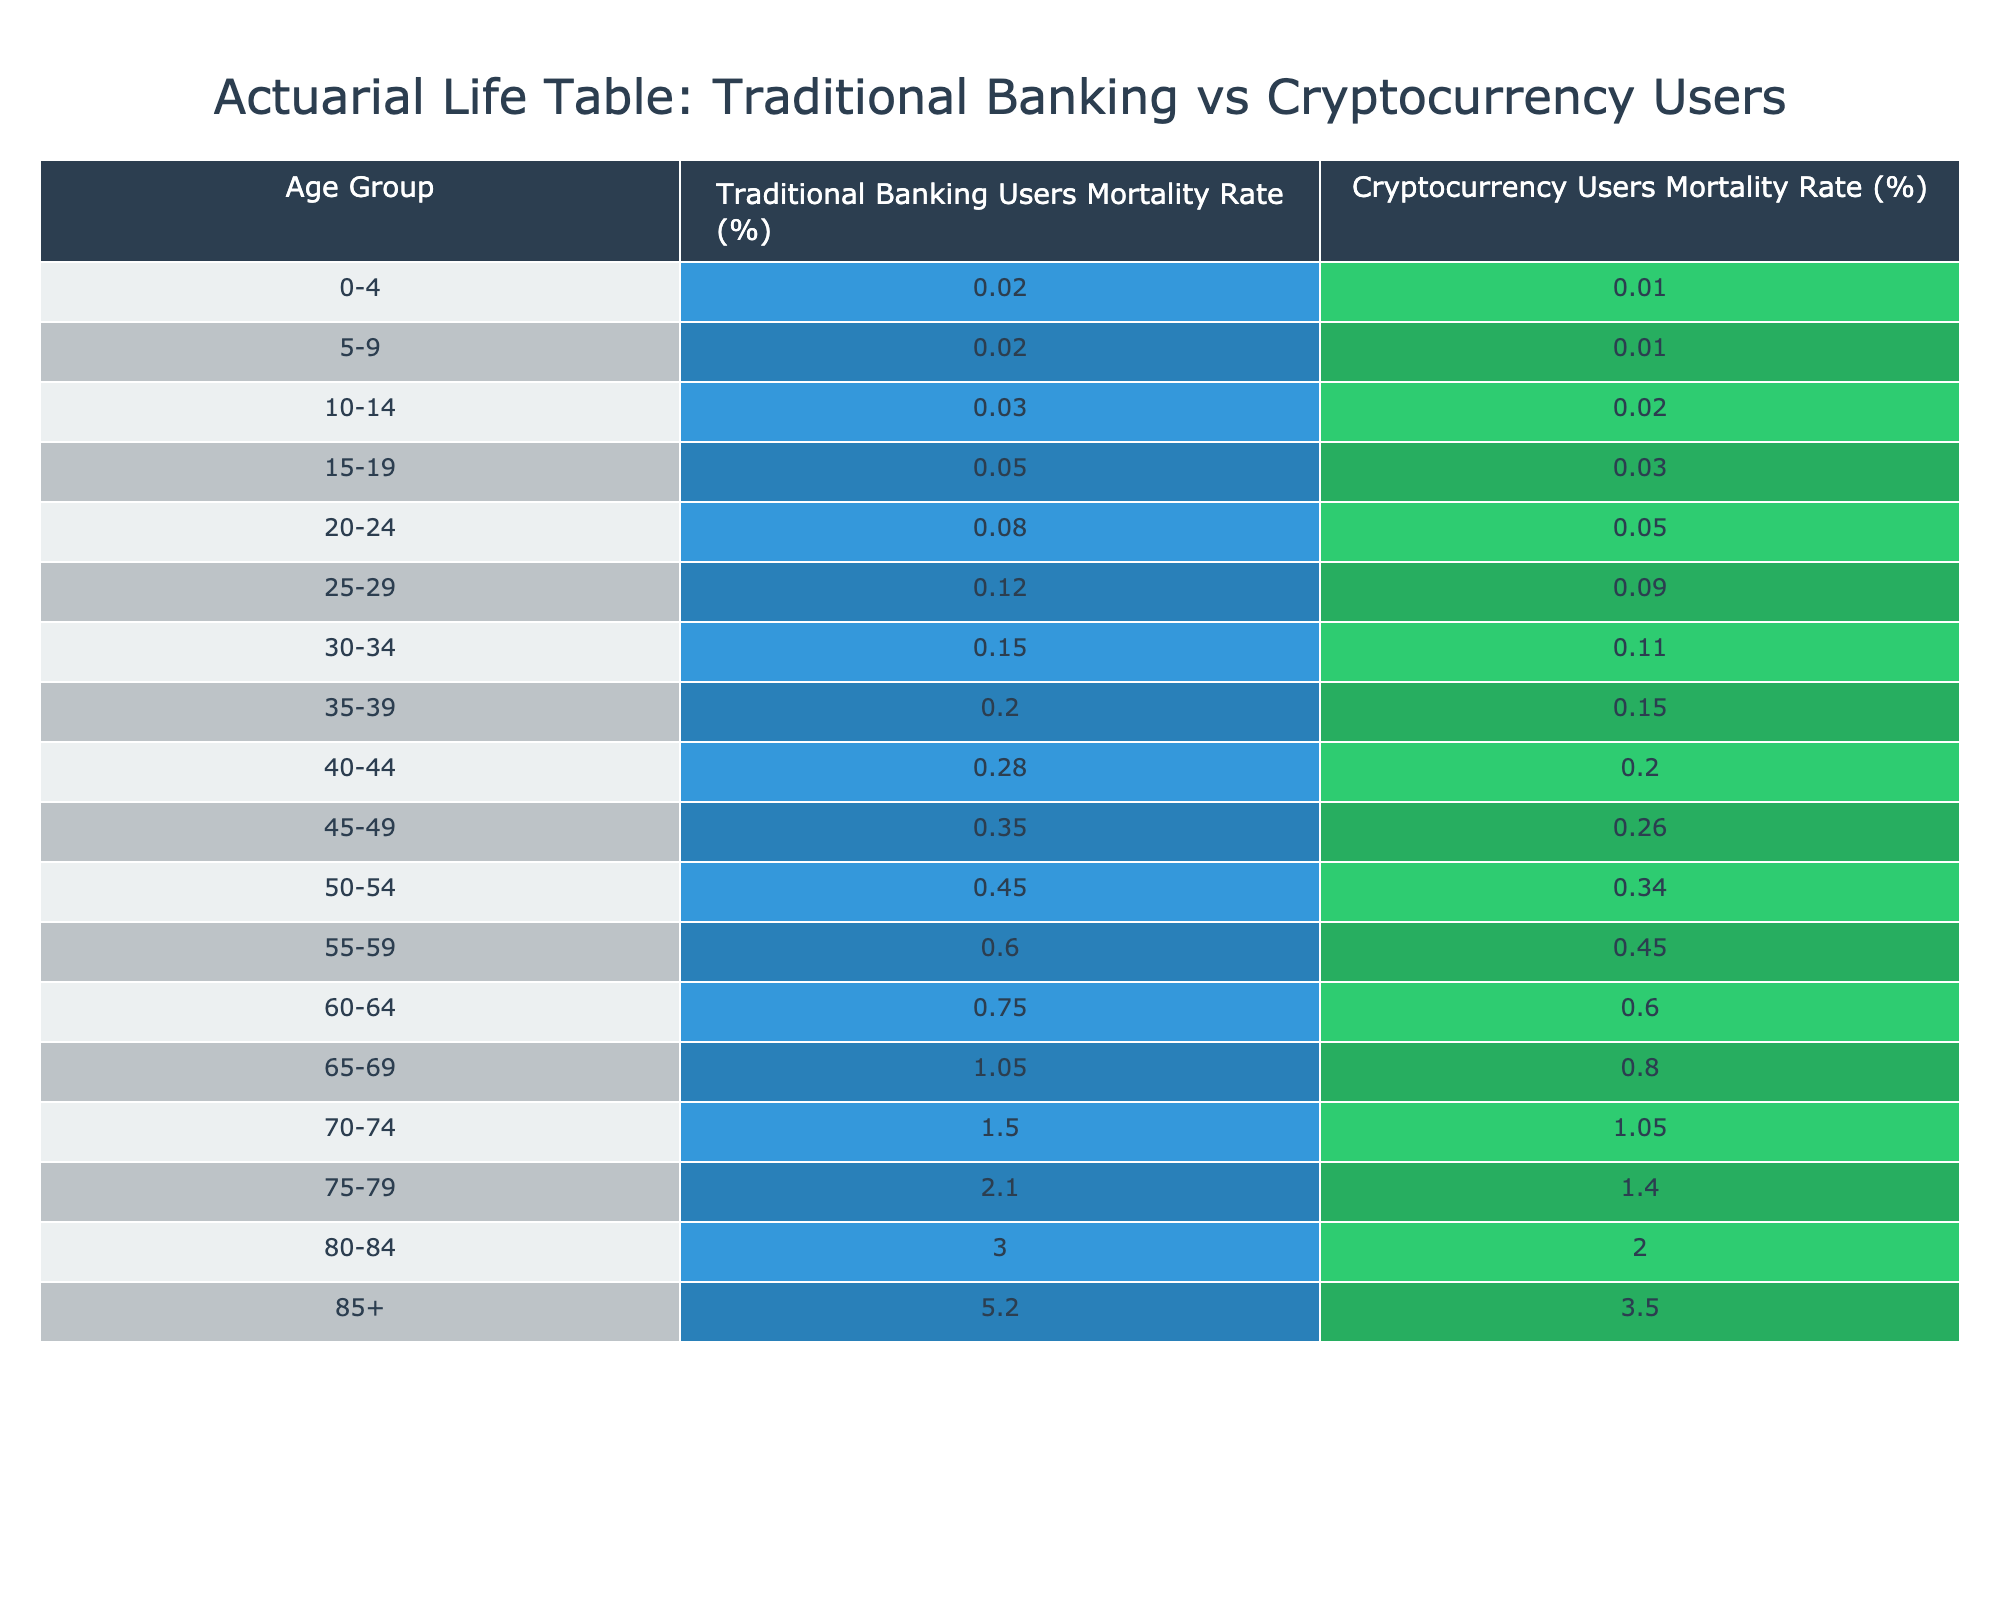What is the mortality rate for cryptocurrency users aged 60-64? The table shows the mortality rate for the age group 60-64 in the column for cryptocurrency users. The rate provided is 0.60%.
Answer: 0.60% Which age group has the highest mortality rate among traditional banking users? By examining the table, the highest mortality rate in the traditional banking users is found in the age group 85+, which is 5.20%.
Answer: 5.20% What is the difference in mortality rates between traditional banking users and cryptocurrency users in the age group 30-34? The mortality rate for traditional banking users in the age group 30-34 is 0.15%, while for cryptocurrency users, it is 0.11%. The difference is calculated as 0.15% - 0.11% = 0.04%.
Answer: 0.04% Is the mortality rate for cryptocurrency users lower than for traditional banking users in the age group 45-49? The mortality rate for traditional banking users in the age group 45-49 is 0.35%, while for cryptocurrency users, it is 0.26%. Since 0.26% is less than 0.35%, the statement is true.
Answer: Yes What is the average mortality rate for ages 50-54 for both groups combined? The mortality rates are 0.45% for traditional banking users and 0.34% for cryptocurrency users. The combined average is calculated as (0.45% + 0.34%) / 2 = 0.395%.
Answer: 0.395% Which age group has a 1.5% mortality rate among traditional banking users? From the table, the age group that has a mortality rate of 1.5% for traditional banking users is 70-74.
Answer: 70-74 If we consider users aged 80-84, what is the percentage difference in mortality rate between the two groups? The mortality rate for traditional banking users aged 80-84 is 3.00% and for cryptocurrency users, it is 2.00%. The difference is calculated as (3.00% - 2.00%) / 3.00% * 100 = 33.33%.
Answer: 33.33% What is the combined mortality rate for users aged 75-79 in both banking systems? The mortality rates are 2.10% for traditional banking users and 1.40% for cryptocurrency users. The combined rate is simply the two rates added together: 2.10% + 1.40% = 3.50%.
Answer: 3.50% 